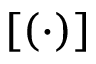<formula> <loc_0><loc_0><loc_500><loc_500>\left [ ( \cdot ) \right ]</formula> 